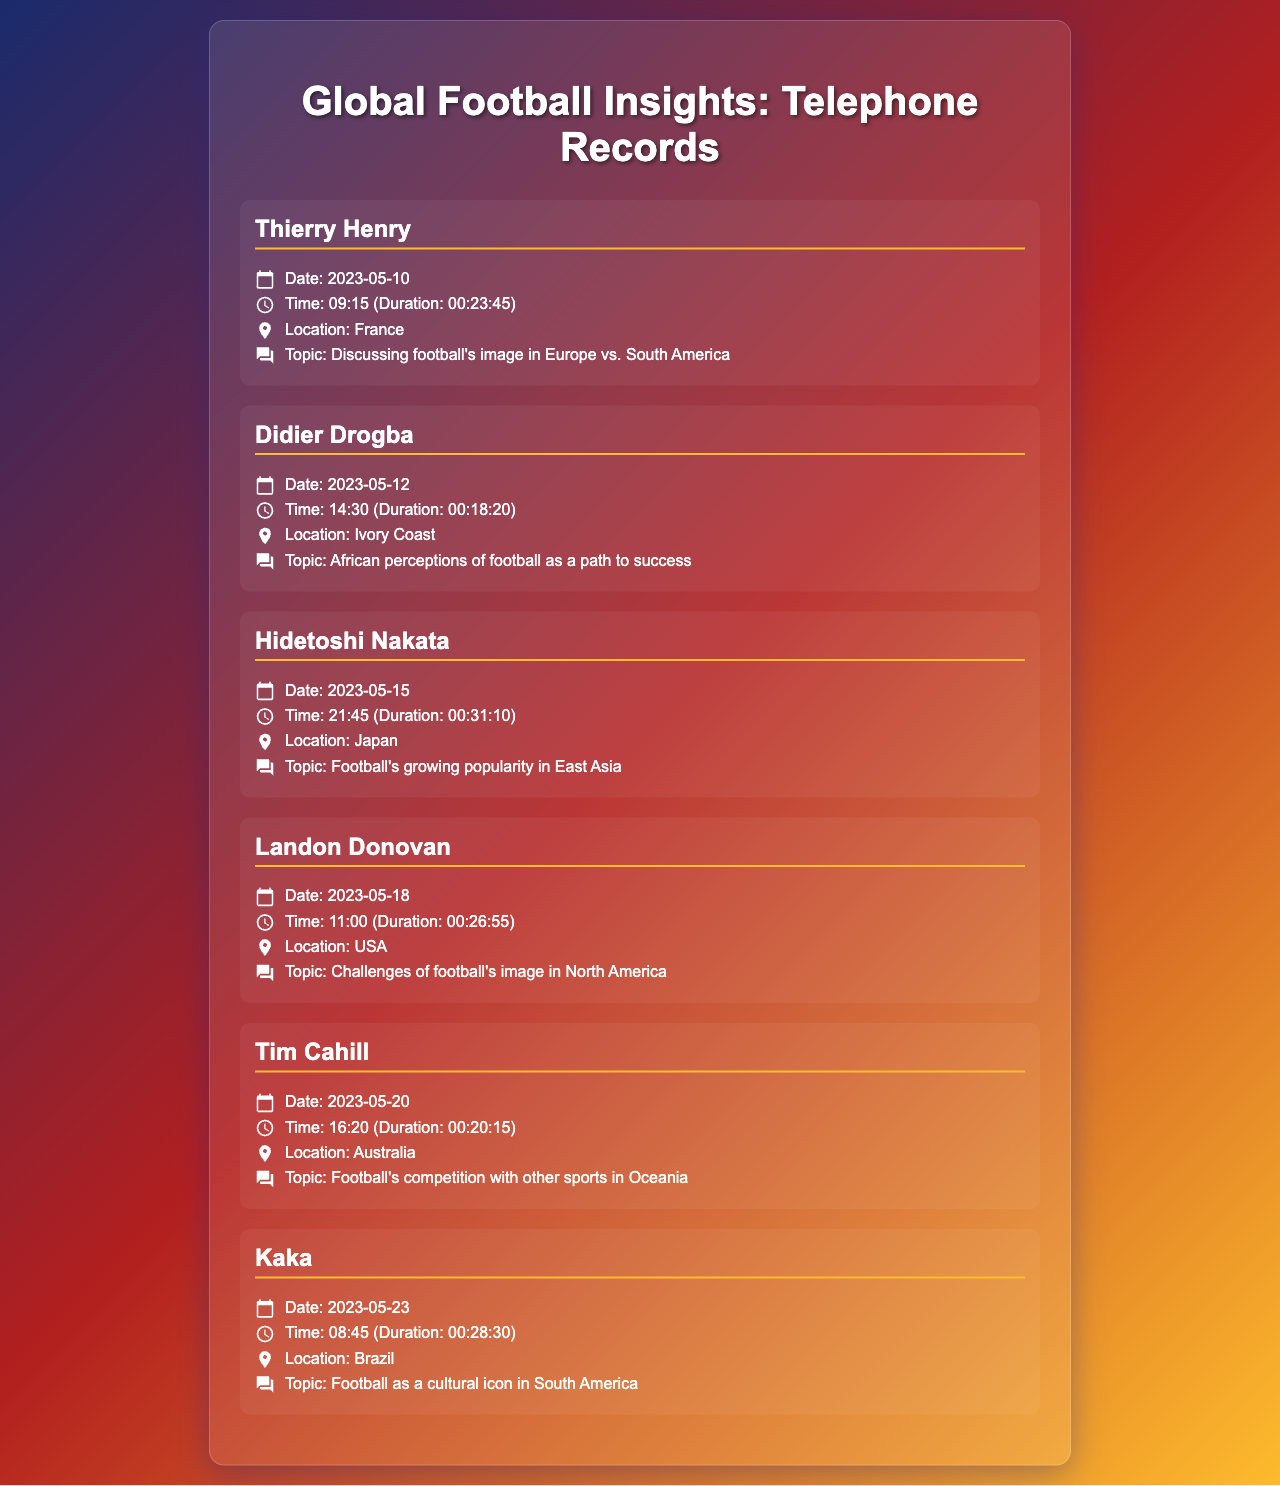What is the date of the call with Thierry Henry? The date of the call is stated clearly in the record for Thierry Henry.
Answer: 2023-05-10 What topic did Didier Drogba discuss? The topic discussed by Didier Drogba is explicitly mentioned in his record.
Answer: African perceptions of football as a path to success How long was the call with Hidetoshi Nakata? The duration of the call is included in the record for Hidetoshi Nakata.
Answer: 00:31:10 What location is associated with the call to Kaka? The location can be found in the record for Kaka.
Answer: Brazil Which former teammate discussed football's image in North America? The specific teammate discussing North America's image is indicated in the document.
Answer: Landon Donovan How many calls were made on May 20th? The document provides information on the calls that occurred on that specific date.
Answer: 1 Which record includes the longest duration call? The call with the longest duration can be identified by comparing the durations listed.
Answer: Hidetoshi Nakata What was the time of the call with Tim Cahill? The call time is explicitly noted in Tim Cahill's record.
Answer: 16:20 What is the common theme among the calls? The overarching theme is implied through multiple records discussing football's perception globally.
Answer: Global perceptions of football 